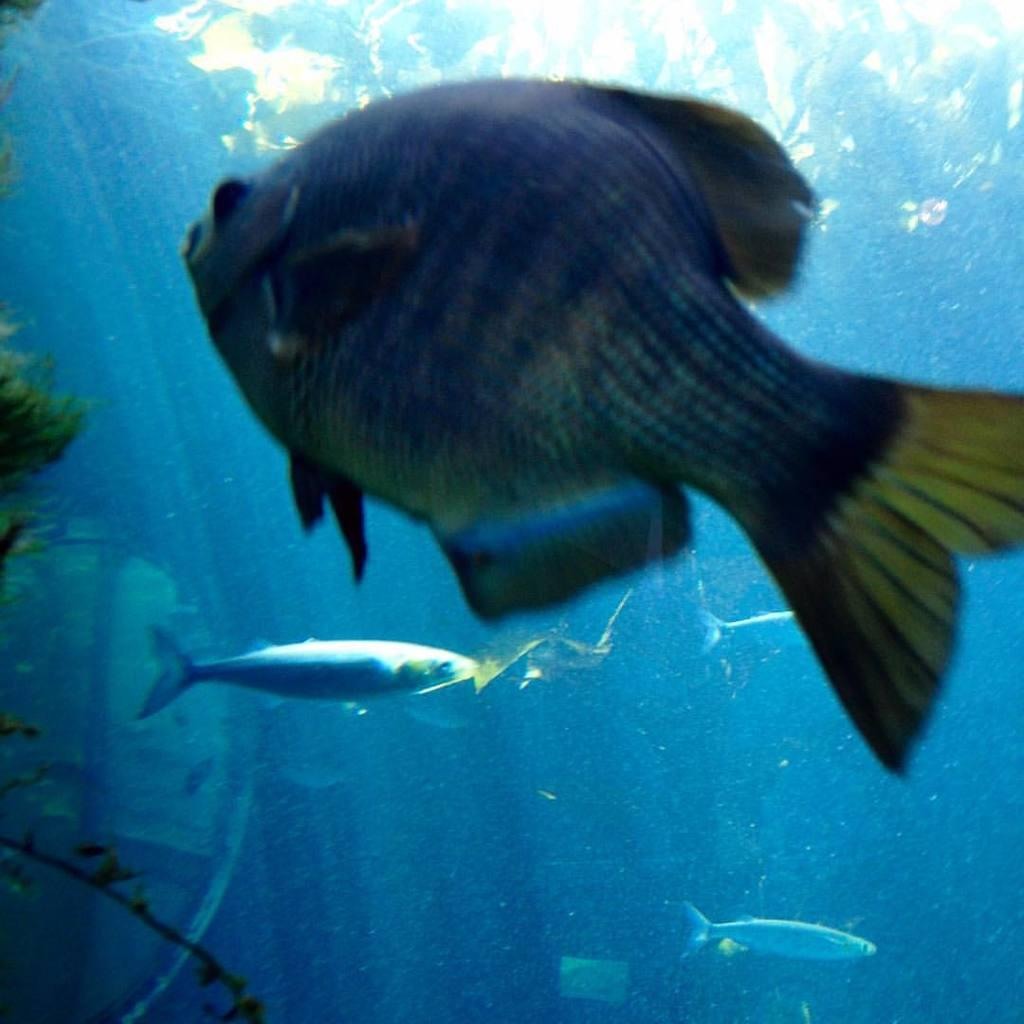What type of animals can be seen in the image? There are fish inside the water in the image. What color are the plants in the image? The plants in the image are green. Can you tell me how many berries are on the plants in the image? There are no berries present in the image; it features fish and green plants. What type of tools might a carpenter use in the image? There is no carpenter or any tools present in the image. 